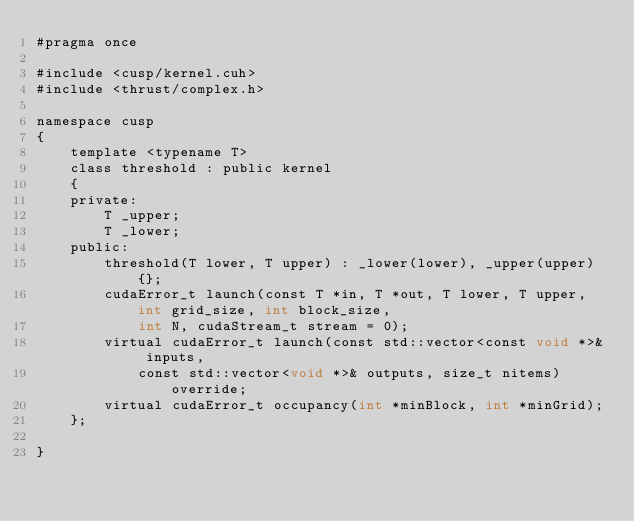Convert code to text. <code><loc_0><loc_0><loc_500><loc_500><_Cuda_>#pragma once

#include <cusp/kernel.cuh>
#include <thrust/complex.h>

namespace cusp
{
    template <typename T>
    class threshold : public kernel
    {
    private:
        T _upper;
        T _lower;
    public:
        threshold(T lower, T upper) : _lower(lower), _upper(upper) {};
        cudaError_t launch(const T *in, T *out, T lower, T upper, int grid_size, int block_size,
            int N, cudaStream_t stream = 0);
        virtual cudaError_t launch(const std::vector<const void *>& inputs,
            const std::vector<void *>& outputs, size_t nitems) override;
        virtual cudaError_t occupancy(int *minBlock, int *minGrid);
    };

}</code> 